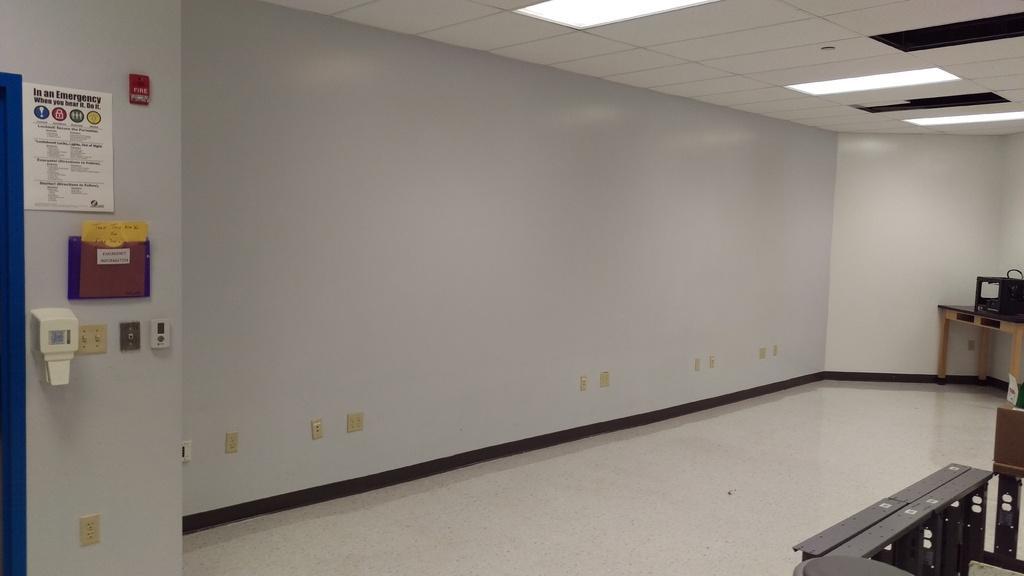How would you summarize this image in a sentence or two? In this image I can see the inner part of the room and I can also see a machine on the table. The table is in brown color, background I can see few boards attached to the wall and the wall is in white color. 